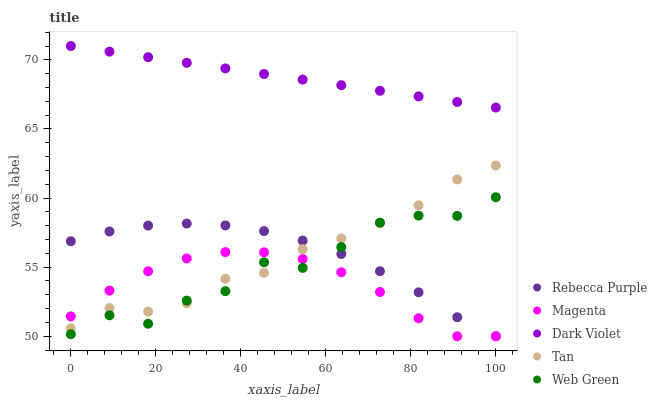Does Magenta have the minimum area under the curve?
Answer yes or no. Yes. Does Dark Violet have the maximum area under the curve?
Answer yes or no. Yes. Does Web Green have the minimum area under the curve?
Answer yes or no. No. Does Web Green have the maximum area under the curve?
Answer yes or no. No. Is Dark Violet the smoothest?
Answer yes or no. Yes. Is Web Green the roughest?
Answer yes or no. Yes. Is Tan the smoothest?
Answer yes or no. No. Is Tan the roughest?
Answer yes or no. No. Does Magenta have the lowest value?
Answer yes or no. Yes. Does Web Green have the lowest value?
Answer yes or no. No. Does Dark Violet have the highest value?
Answer yes or no. Yes. Does Web Green have the highest value?
Answer yes or no. No. Is Rebecca Purple less than Dark Violet?
Answer yes or no. Yes. Is Dark Violet greater than Tan?
Answer yes or no. Yes. Does Rebecca Purple intersect Web Green?
Answer yes or no. Yes. Is Rebecca Purple less than Web Green?
Answer yes or no. No. Is Rebecca Purple greater than Web Green?
Answer yes or no. No. Does Rebecca Purple intersect Dark Violet?
Answer yes or no. No. 